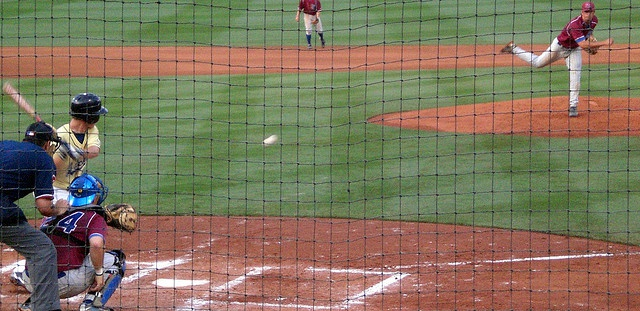Describe the objects in this image and their specific colors. I can see people in olive, black, gray, navy, and darkblue tones, people in olive, black, gray, maroon, and darkgray tones, people in olive, black, gray, and ivory tones, people in olive, lightgray, brown, darkgray, and gray tones, and people in olive, darkgray, maroon, gray, and pink tones in this image. 